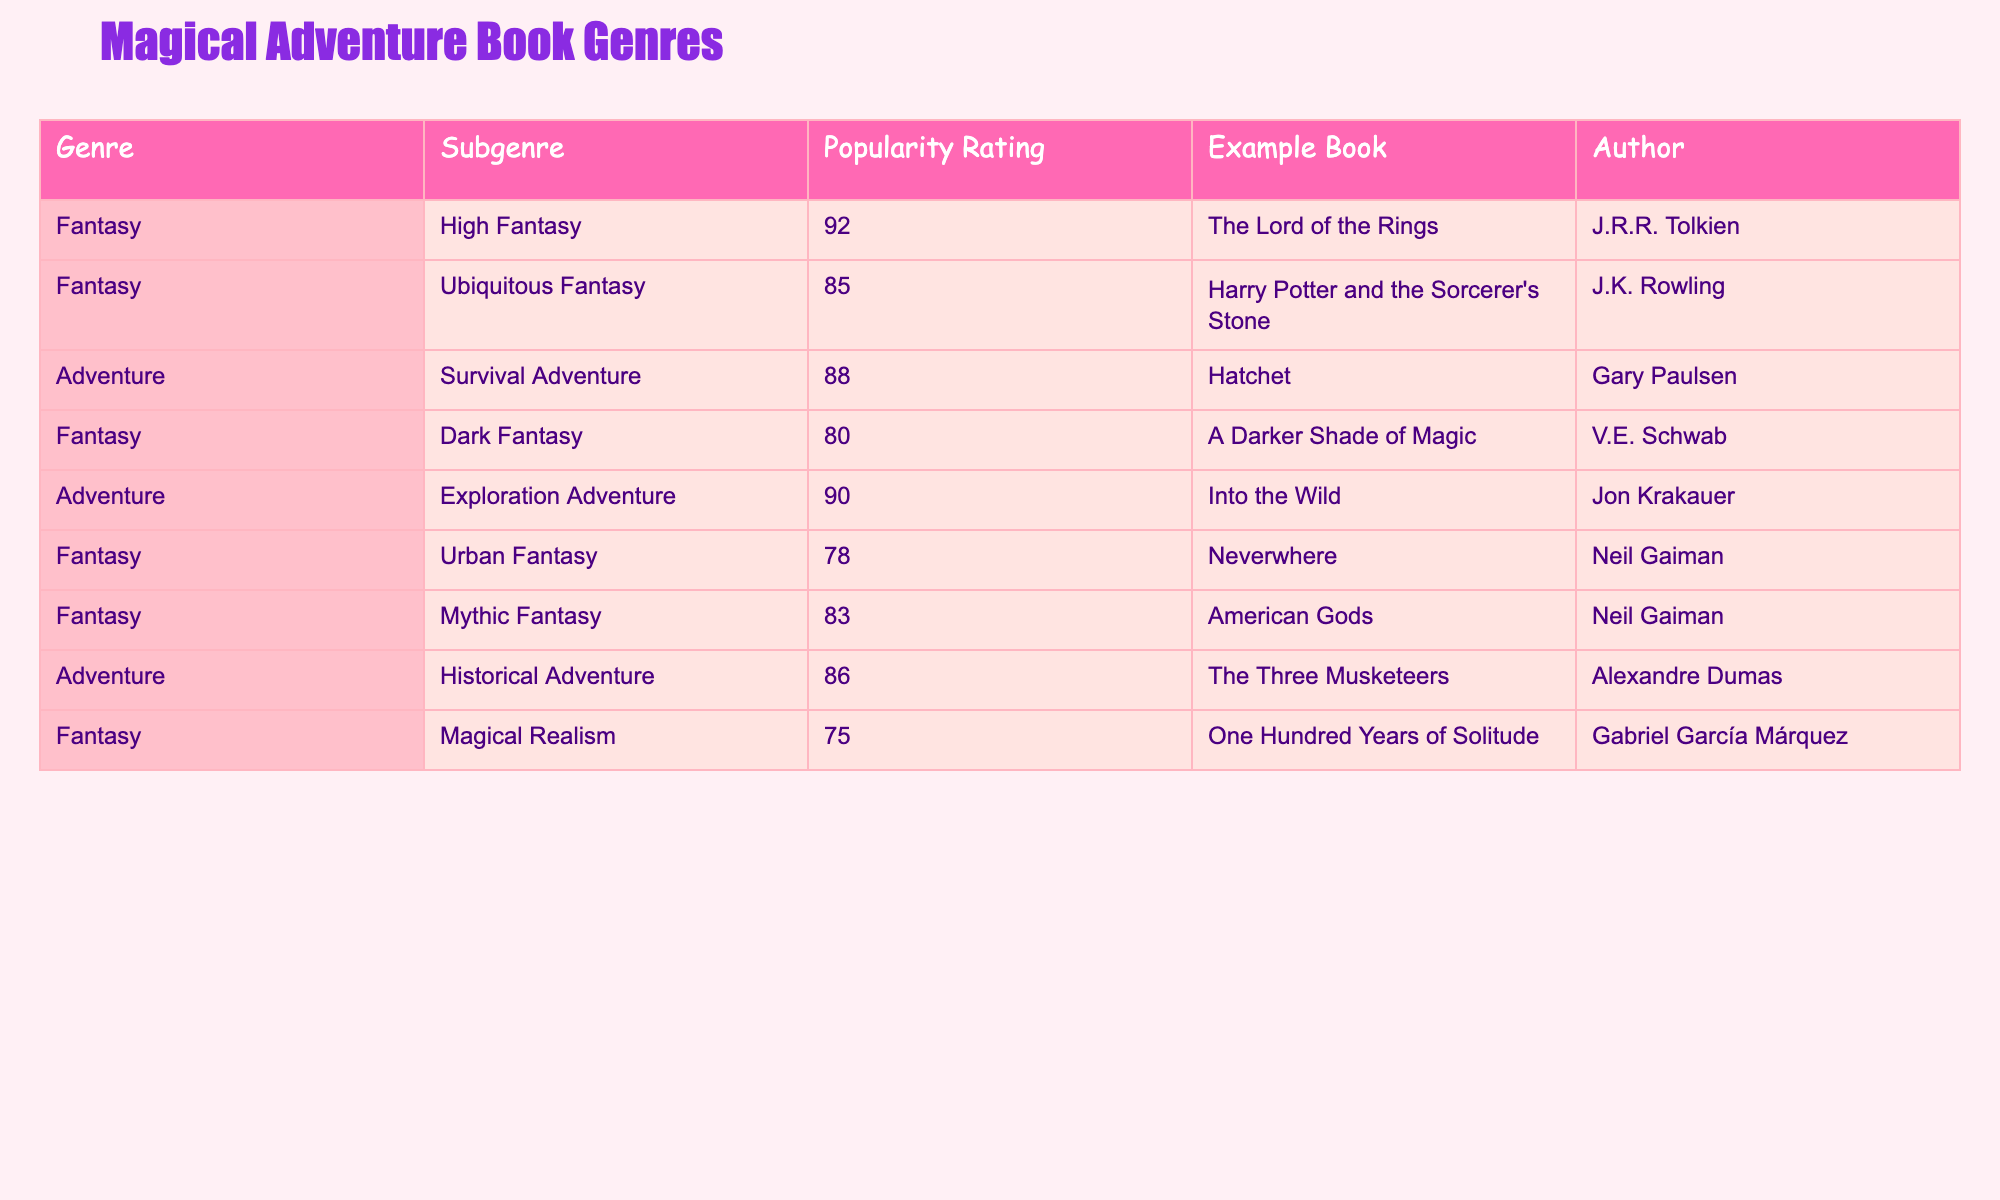What is the popularity rating of "The Lord of the Rings"? According to the table, the popularity rating for "The Lord of the Rings" is listed directly under the "Popularity Rating" column. It shows a value of 92.
Answer: 92 Which adventure subgenre has the highest popularity rating? Looking at the "Adventure" subgenre in the table, the two ratings for "Survival Adventure" and "Exploration Adventure" are compared: 88 for "Survival Adventure" and 90 for "Exploration Adventure." Therefore, "Exploration Adventure" has the highest rating of 90.
Answer: 90 Is "Harry Potter and the Sorcerer's Stone" categorized under Adventure? The table specifies that "Harry Potter and the Sorcerer's Stone" is listed under the "Fantasy" genre, not under "Adventure," so it is not categorized as an Adventure book.
Answer: No What is the average popularity rating for all Fantasy subgenres? The ratings for Fantasy subgenres are: High Fantasy (92), Ubiquitous Fantasy (85), Dark Fantasy (80), Urban Fantasy (78), Mythic Fantasy (83), and Magical Realism (75). Adding those gives us 92 + 85 + 80 + 78 + 83 + 75 = 493. There are 6 subgenres, so the average is 493 / 6 = 82.17.
Answer: 82.17 Which author has written the most popular adventure book according to this table? The adventure books listed are "Hatchet" (88), "Into the Wild" (90), and "The Three Musketeers" (86). Among these, "Into the Wild" has the highest popularity rating of 90, and it is authored by Jon Krakauer. Therefore, Jon Krakauer is the author of the most popular adventure book.
Answer: Jon Krakauer How many Fantasy books have a popularity rating above 80? The ratings for the Fantasy books in the table are as follows: High Fantasy (92), Ubiquitous Fantasy (85), Dark Fantasy (80), Urban Fantasy (78), Mythic Fantasy (83), and Magical Realism (75). The books with ratings above 80 are: High Fantasy (92), Ubiquitous Fantasy (85), and Mythic Fantasy (83). That's a total of 3 Fantasy books.
Answer: 3 What is the difference in popularity ratings between the highest-rated adventure and fantasy subgenres? The highest-rated fantasy book is "The Lord of the Rings" with a rating of 92. The highest-rated adventure book is "Into the Wild" with a rating of 90. The difference between these ratings is 92 - 90 = 2.
Answer: 2 Which genre has more subgenres listed in the table? By examining the table, Fantasy has 6 subgenres (High, Ubiquitous, Dark, Urban, Mythic, and Magical Realism) while Adventure has 3 subgenres (Survival, Exploration, and Historical). Since 6 is greater than 3, Fantasy has more subgenres.
Answer: Fantasy What is the lowest popularity rating among the listed books? The ratings provided in the table are: 92, 85, 88, 80, 90, 78, 83, 86, 75. The minimum of these values is 75 from "One Hundred Years of Solitude."
Answer: 75 